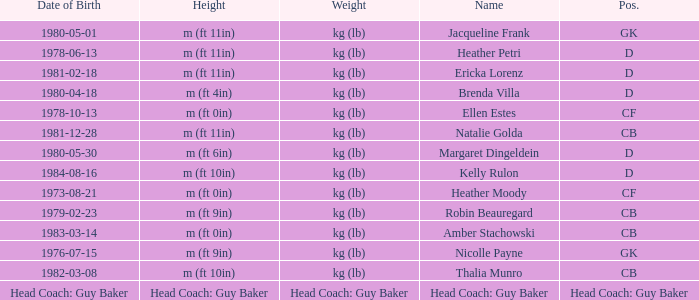Born on 1973-08-21, what is the cf's name? Heather Moody. 